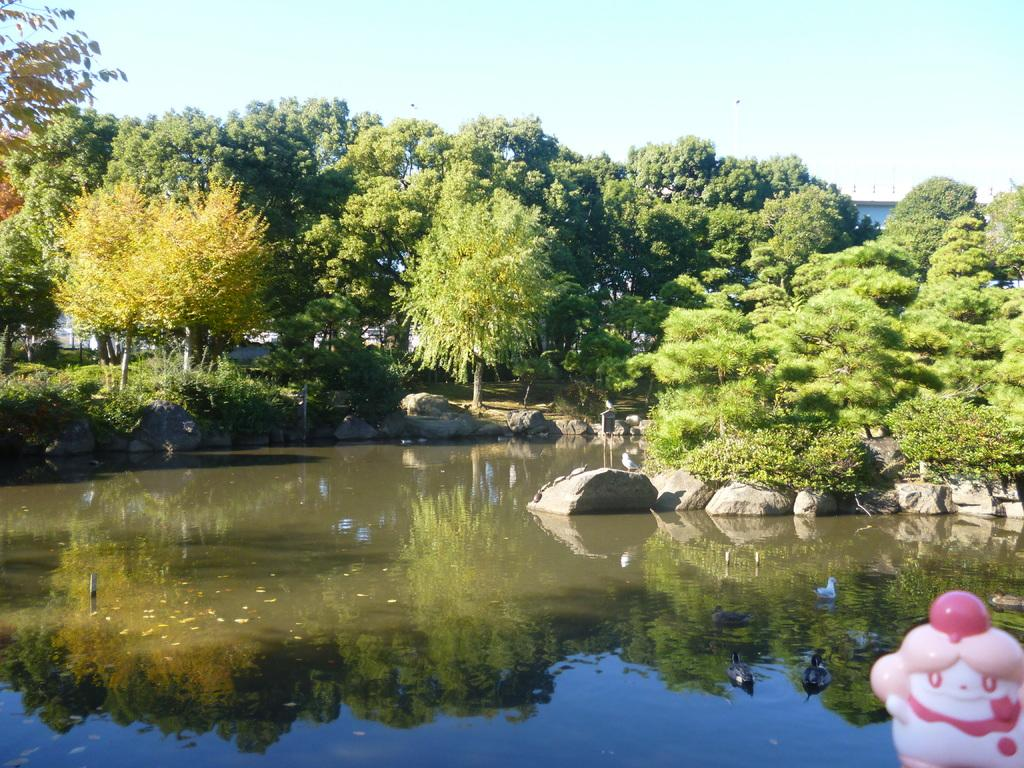What is the main subject in the middle of the image? There is a pond in the middle of the image. What can be seen in the background of the image? There are trees and the sky visible in the background of the image. Where is the church located in the image? There is no church present in the image; it features a pond and trees in the background. What type of party is being held near the pond in the image? There is no party present in the image; it only shows a pond and trees in the background. 